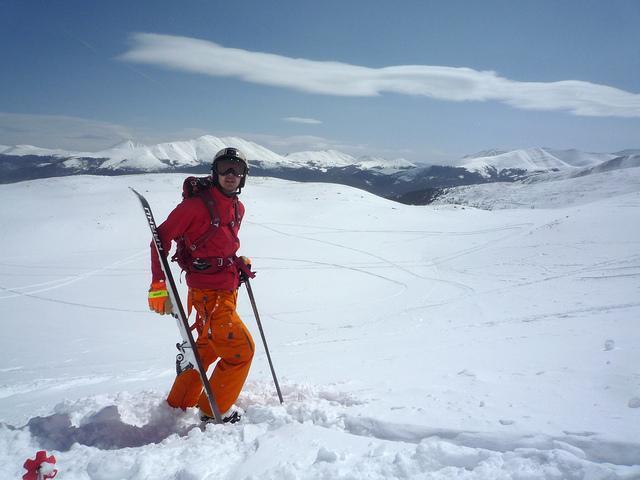How many apples do you see?
Give a very brief answer. 0. 